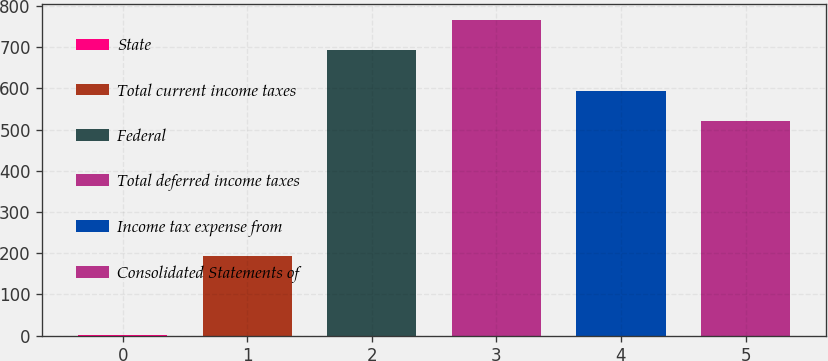Convert chart. <chart><loc_0><loc_0><loc_500><loc_500><bar_chart><fcel>State<fcel>Total current income taxes<fcel>Federal<fcel>Total deferred income taxes<fcel>Income tax expense from<fcel>Consolidated Statements of<nl><fcel>1<fcel>192<fcel>694<fcel>766<fcel>593<fcel>521<nl></chart> 